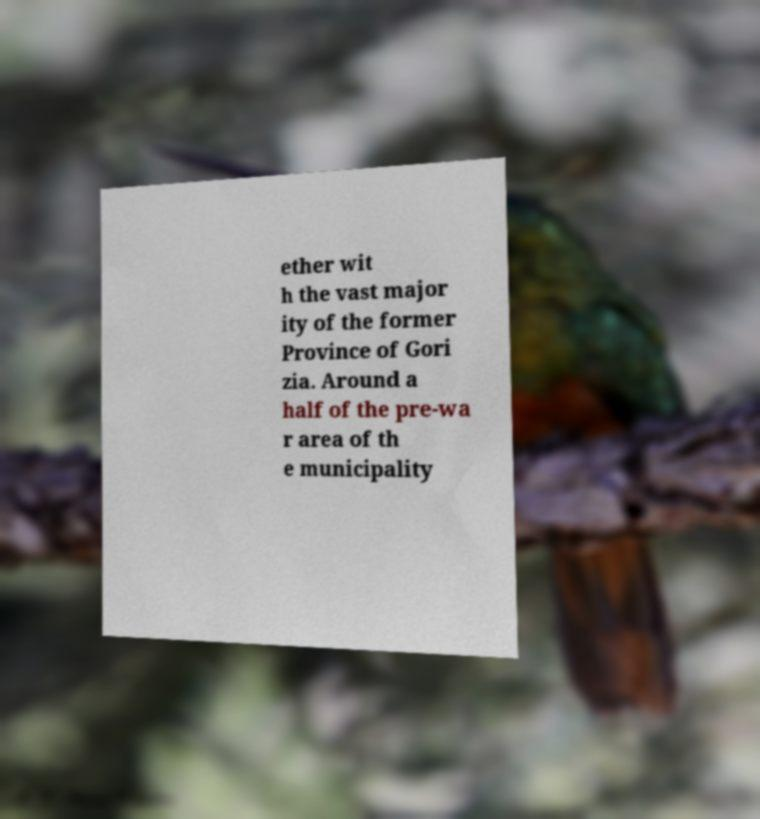Can you accurately transcribe the text from the provided image for me? ether wit h the vast major ity of the former Province of Gori zia. Around a half of the pre-wa r area of th e municipality 